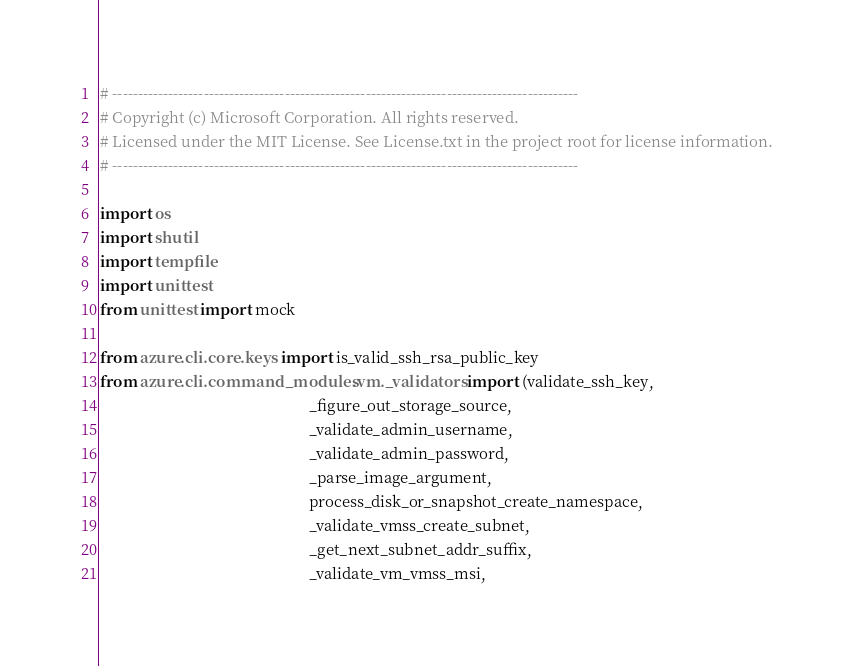<code> <loc_0><loc_0><loc_500><loc_500><_Python_># --------------------------------------------------------------------------------------------
# Copyright (c) Microsoft Corporation. All rights reserved.
# Licensed under the MIT License. See License.txt in the project root for license information.
# --------------------------------------------------------------------------------------------

import os
import shutil
import tempfile
import unittest
from unittest import mock

from azure.cli.core.keys import is_valid_ssh_rsa_public_key
from azure.cli.command_modules.vm._validators import (validate_ssh_key,
                                                      _figure_out_storage_source,
                                                      _validate_admin_username,
                                                      _validate_admin_password,
                                                      _parse_image_argument,
                                                      process_disk_or_snapshot_create_namespace,
                                                      _validate_vmss_create_subnet,
                                                      _get_next_subnet_addr_suffix,
                                                      _validate_vm_vmss_msi,</code> 